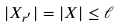<formula> <loc_0><loc_0><loc_500><loc_500>| X _ { r ^ { \prime } } | = | X | \leq \ell</formula> 